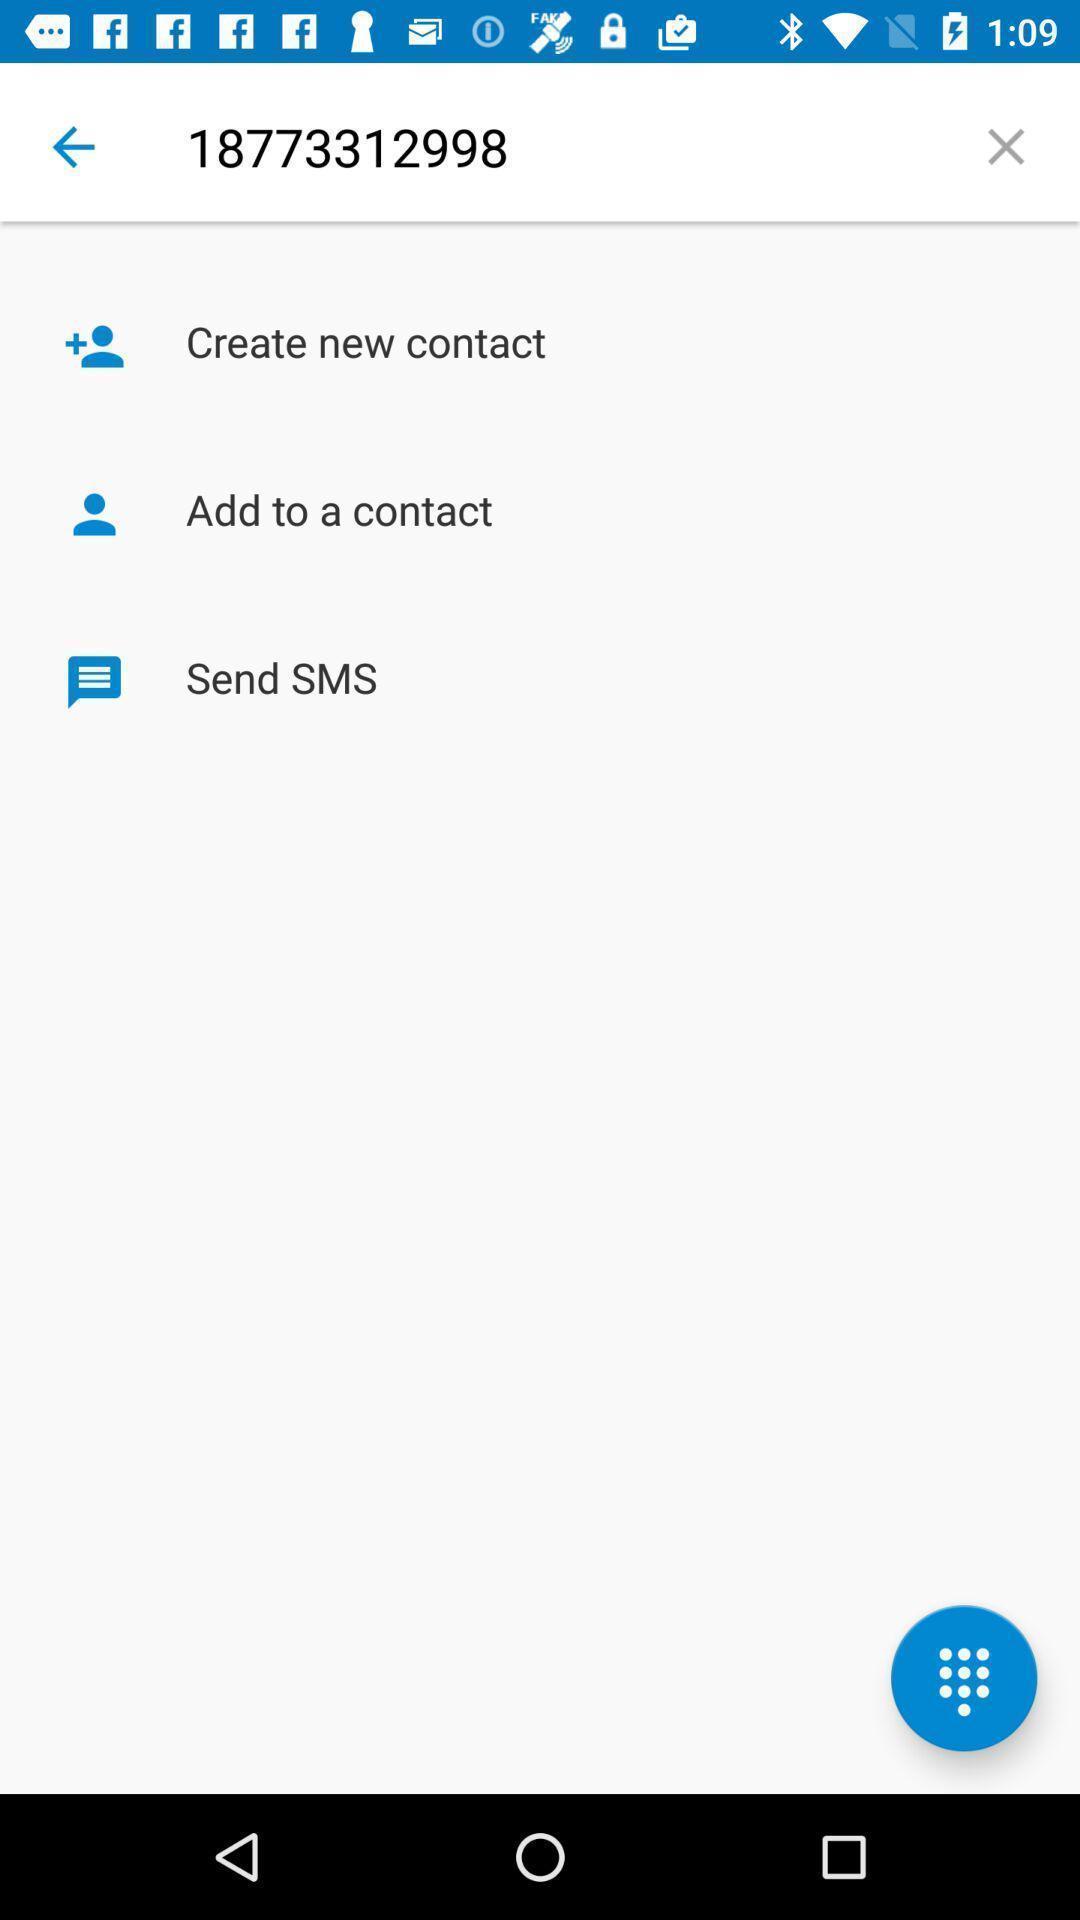Tell me what you see in this picture. Screen showing number with options. 